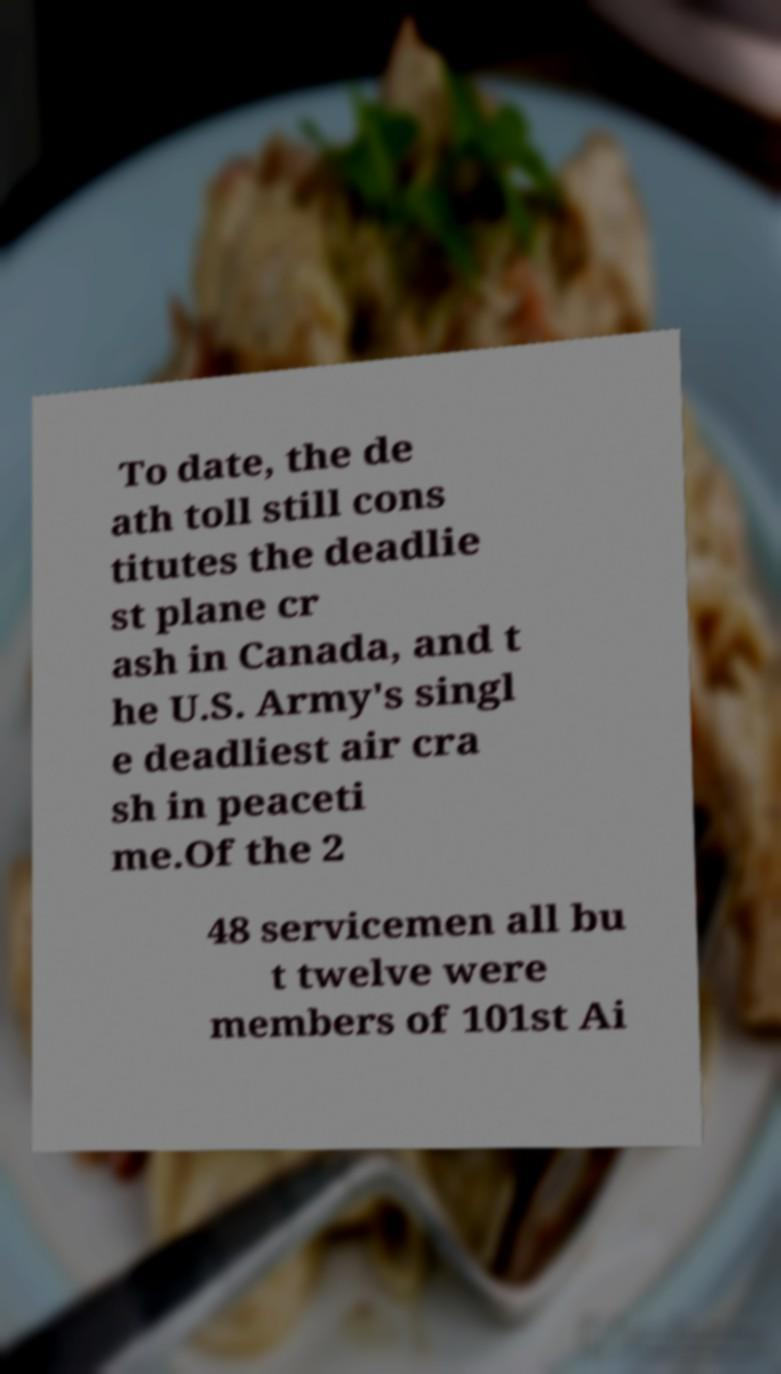Could you assist in decoding the text presented in this image and type it out clearly? To date, the de ath toll still cons titutes the deadlie st plane cr ash in Canada, and t he U.S. Army's singl e deadliest air cra sh in peaceti me.Of the 2 48 servicemen all bu t twelve were members of 101st Ai 